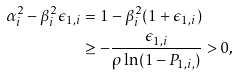<formula> <loc_0><loc_0><loc_500><loc_500>\alpha ^ { 2 } _ { i } - \beta _ { i } ^ { 2 } \epsilon _ { 1 , i } & = 1 - \beta _ { i } ^ { 2 } ( 1 + \epsilon _ { 1 , i } ) \\ & \geq - \frac { \epsilon _ { 1 , i } } { \rho \ln ( 1 - P _ { 1 , i , } ) } > 0 ,</formula> 